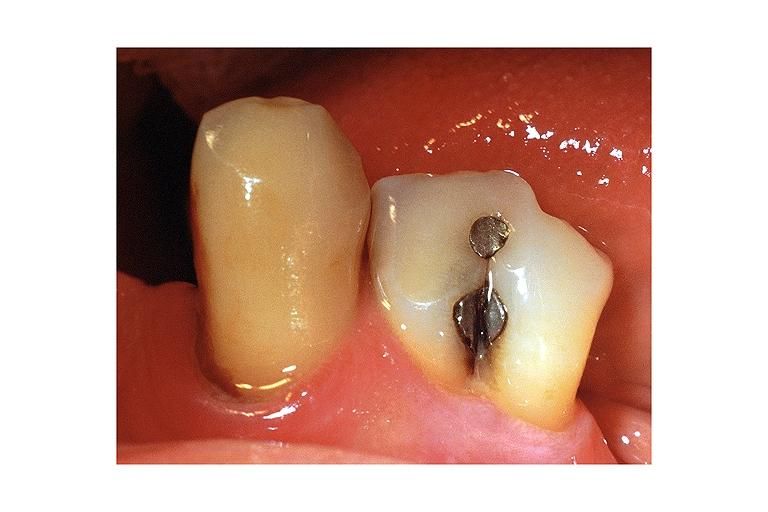does cord show fusion?
Answer the question using a single word or phrase. No 